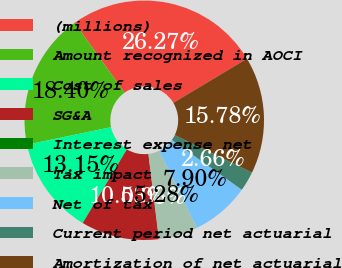Convert chart to OTSL. <chart><loc_0><loc_0><loc_500><loc_500><pie_chart><fcel>(millions)<fcel>Amount recognized in AOCI<fcel>Cost of sales<fcel>SG&A<fcel>Interest expense net<fcel>Tax impact<fcel>Net of tax<fcel>Current period net actuarial<fcel>Amortization of net actuarial<nl><fcel>26.27%<fcel>18.4%<fcel>13.15%<fcel>10.53%<fcel>0.03%<fcel>5.28%<fcel>7.9%<fcel>2.66%<fcel>15.78%<nl></chart> 